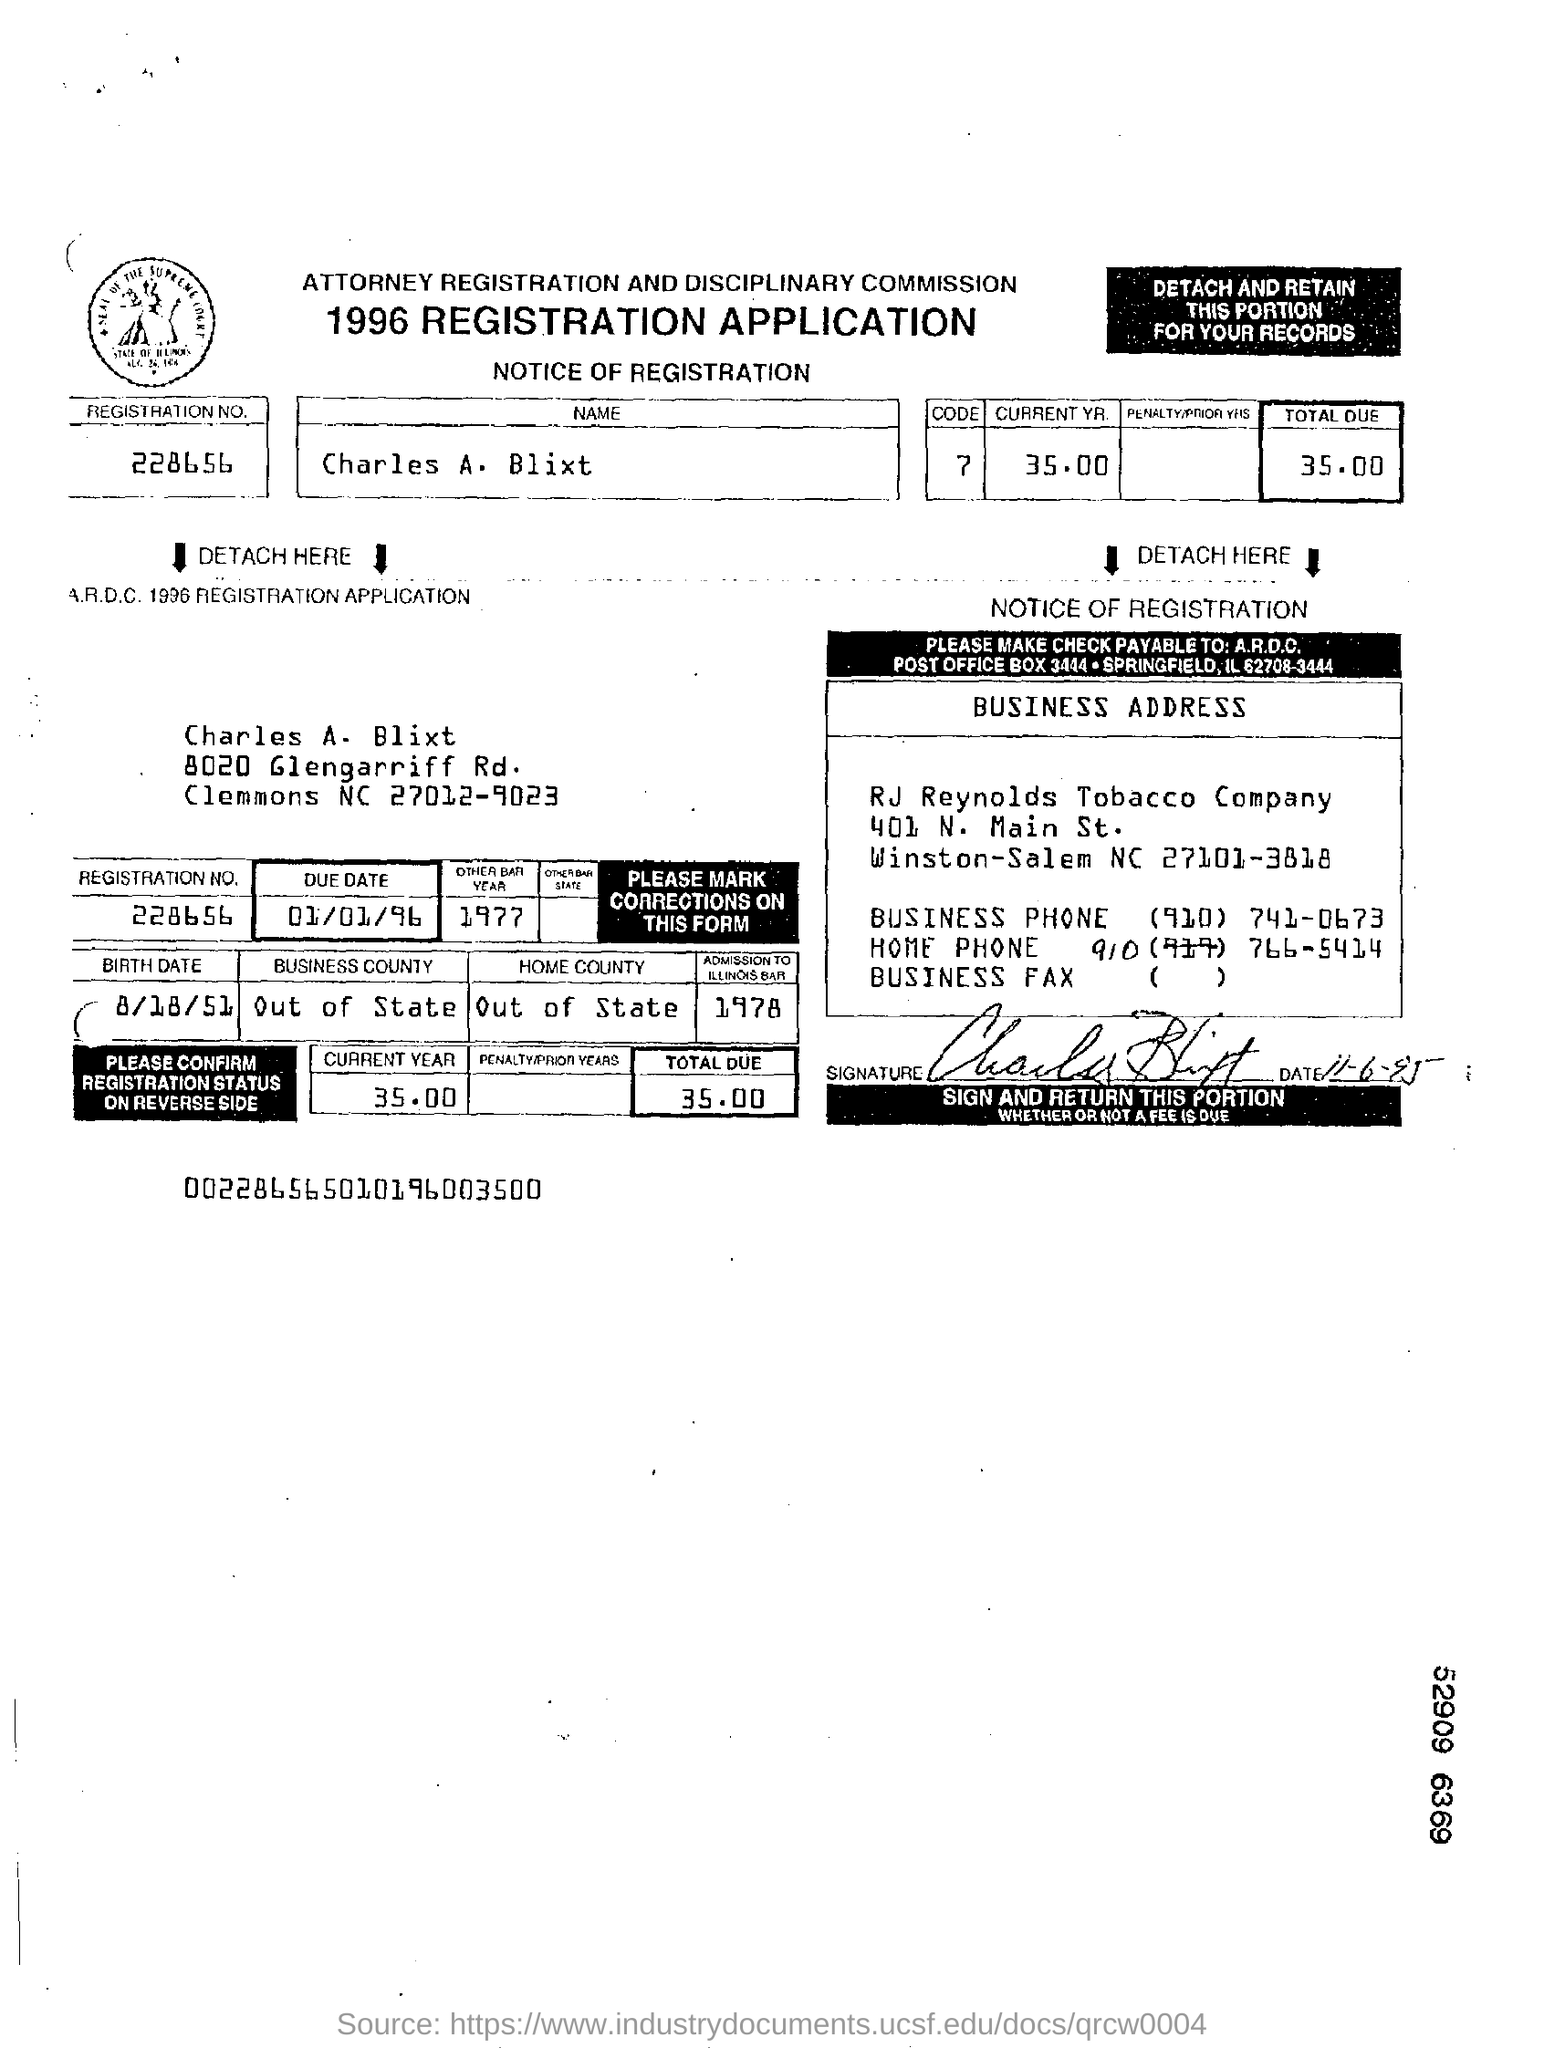What is the name of the applicant?
Provide a succinct answer. Charles A. Blixt. What is the registration No. given in the application?
Offer a terse response. 228656. What is the total amount due given in the application?
Provide a succinct answer. 35.00. What is the due date mentioned in the application?
Give a very brief answer. 01/01/96. What is the birth date of Charles A. Blixt?
Make the answer very short. 8/18/51. 